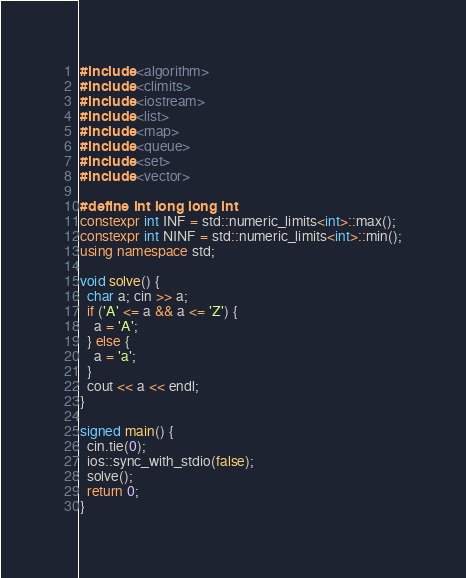Convert code to text. <code><loc_0><loc_0><loc_500><loc_500><_C++_>#include <algorithm>
#include <climits>
#include <iostream>
#include <list>
#include <map>
#include <queue>
#include <set>
#include <vector>

#define int long long int
constexpr int INF = std::numeric_limits<int>::max();
constexpr int NINF = std::numeric_limits<int>::min();
using namespace std;

void solve() {
  char a; cin >> a;
  if ('A' <= a && a <= 'Z') {
    a = 'A';
  } else {
    a = 'a';
  }
  cout << a << endl;
}

signed main() {
  cin.tie(0);
  ios::sync_with_stdio(false);
  solve();
  return 0;
}
</code> 